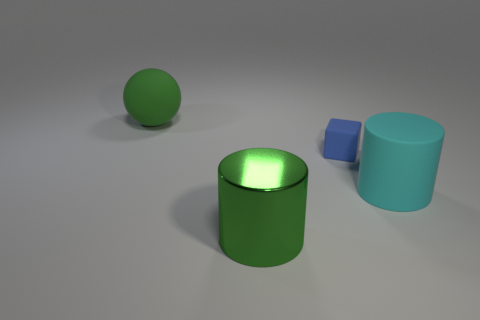There is a large green object in front of the large green rubber ball; how many objects are behind it?
Your answer should be compact. 3. Are there more blue objects that are in front of the small blue object than large metal cylinders that are to the right of the cyan thing?
Keep it short and to the point. No. What is the green ball made of?
Keep it short and to the point. Rubber. Are there any yellow metallic balls of the same size as the matte cylinder?
Offer a terse response. No. What material is the green cylinder that is the same size as the sphere?
Your answer should be compact. Metal. What number of large cyan cylinders are there?
Your response must be concise. 1. What size is the cylinder that is on the right side of the big green shiny thing?
Offer a very short reply. Large. Are there the same number of tiny matte cubes that are on the left side of the blue block and large shiny cubes?
Make the answer very short. Yes. Are there any large matte objects of the same shape as the green metallic thing?
Give a very brief answer. Yes. There is a big object that is in front of the large green ball and behind the big shiny cylinder; what is its shape?
Provide a succinct answer. Cylinder. 